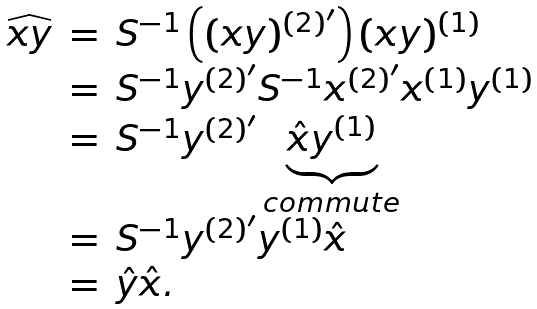Convert formula to latex. <formula><loc_0><loc_0><loc_500><loc_500>\begin{array} { r c l } \widehat { x y } & = & S ^ { - 1 } \left ( ( x y ) ^ { ( 2 ) ^ { \prime } } \right ) ( x y ) ^ { ( 1 ) } \\ & = & S ^ { - 1 } y ^ { ( 2 ) ^ { \prime } } S ^ { - 1 } x ^ { ( 2 ) ^ { \prime } } x ^ { ( 1 ) } y ^ { ( 1 ) } \\ & = & S ^ { - 1 } y ^ { ( 2 ) ^ { \prime } } \underbrace { \hat { x } y ^ { ( 1 ) } } _ { c o m m u t e } \\ & = & S ^ { - 1 } y ^ { ( 2 ) ^ { \prime } } y ^ { ( 1 ) } \hat { x } \\ & = & \hat { y } \hat { x } . \end{array}</formula> 